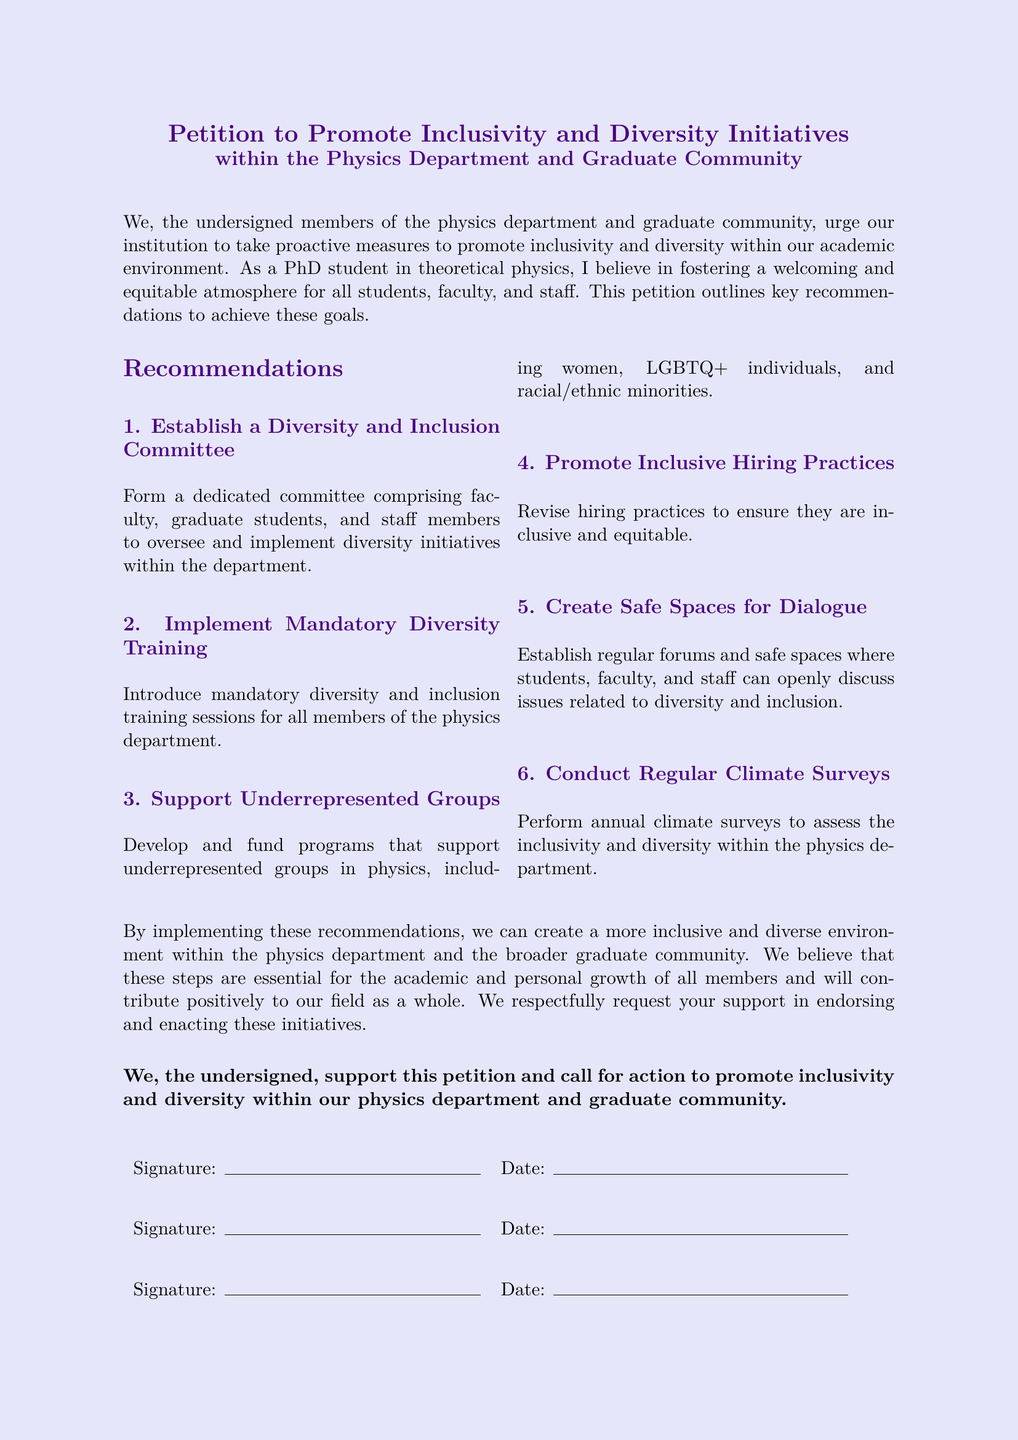What is the title of the petition? The title is stated at the top of the document and emphasizes its purpose.
Answer: Petition to Promote Inclusivity and Diversity Initiatives What type of committee is recommended in the petition? The petition suggests the formation of a specific type of committee focusing on inclusivity.
Answer: Diversity and Inclusion Committee Who should undergo mandatory training according to the recommendations? The petition outlines that all members of a specific group should participate in training.
Answer: All members of the physics department Which groups are mentioned as needing support? The petition emphasizes the importance of supporting certain marginalized groups within the physics field.
Answer: Women, LGBTQ+ individuals, and racial/ethnic minorities How often should climate surveys be conducted? The document specifies how frequently assessments of the department's inclusivity climate should happen.
Answer: Annually What is the primary goal of this petition? The petition outlines a central aim that reflects the desires of the community members.
Answer: To promote inclusivity and diversity How many main recommendations are provided in the petition? The petition lists a specific number of key suggestions for achieving its goals.
Answer: Six 